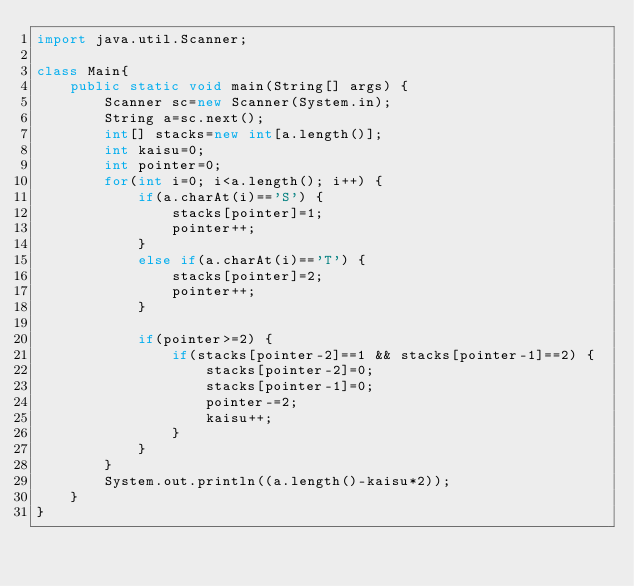Convert code to text. <code><loc_0><loc_0><loc_500><loc_500><_Java_>import java.util.Scanner;

class Main{
	public static void main(String[] args) {
		Scanner sc=new Scanner(System.in);
		String a=sc.next();
		int[] stacks=new int[a.length()];
		int kaisu=0;
		int pointer=0;
		for(int i=0; i<a.length(); i++) {
			if(a.charAt(i)=='S') {
				stacks[pointer]=1;
				pointer++;
			}
			else if(a.charAt(i)=='T') {
				stacks[pointer]=2;
				pointer++;
			}

			if(pointer>=2) {
				if(stacks[pointer-2]==1 && stacks[pointer-1]==2) {
					stacks[pointer-2]=0;
					stacks[pointer-1]=0;
					pointer-=2;
					kaisu++;
				}
			}
		}
		System.out.println((a.length()-kaisu*2));
	}
}</code> 